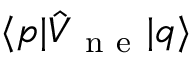<formula> <loc_0><loc_0><loc_500><loc_500>\langle p | \hat { V } _ { n e } | q \rangle</formula> 